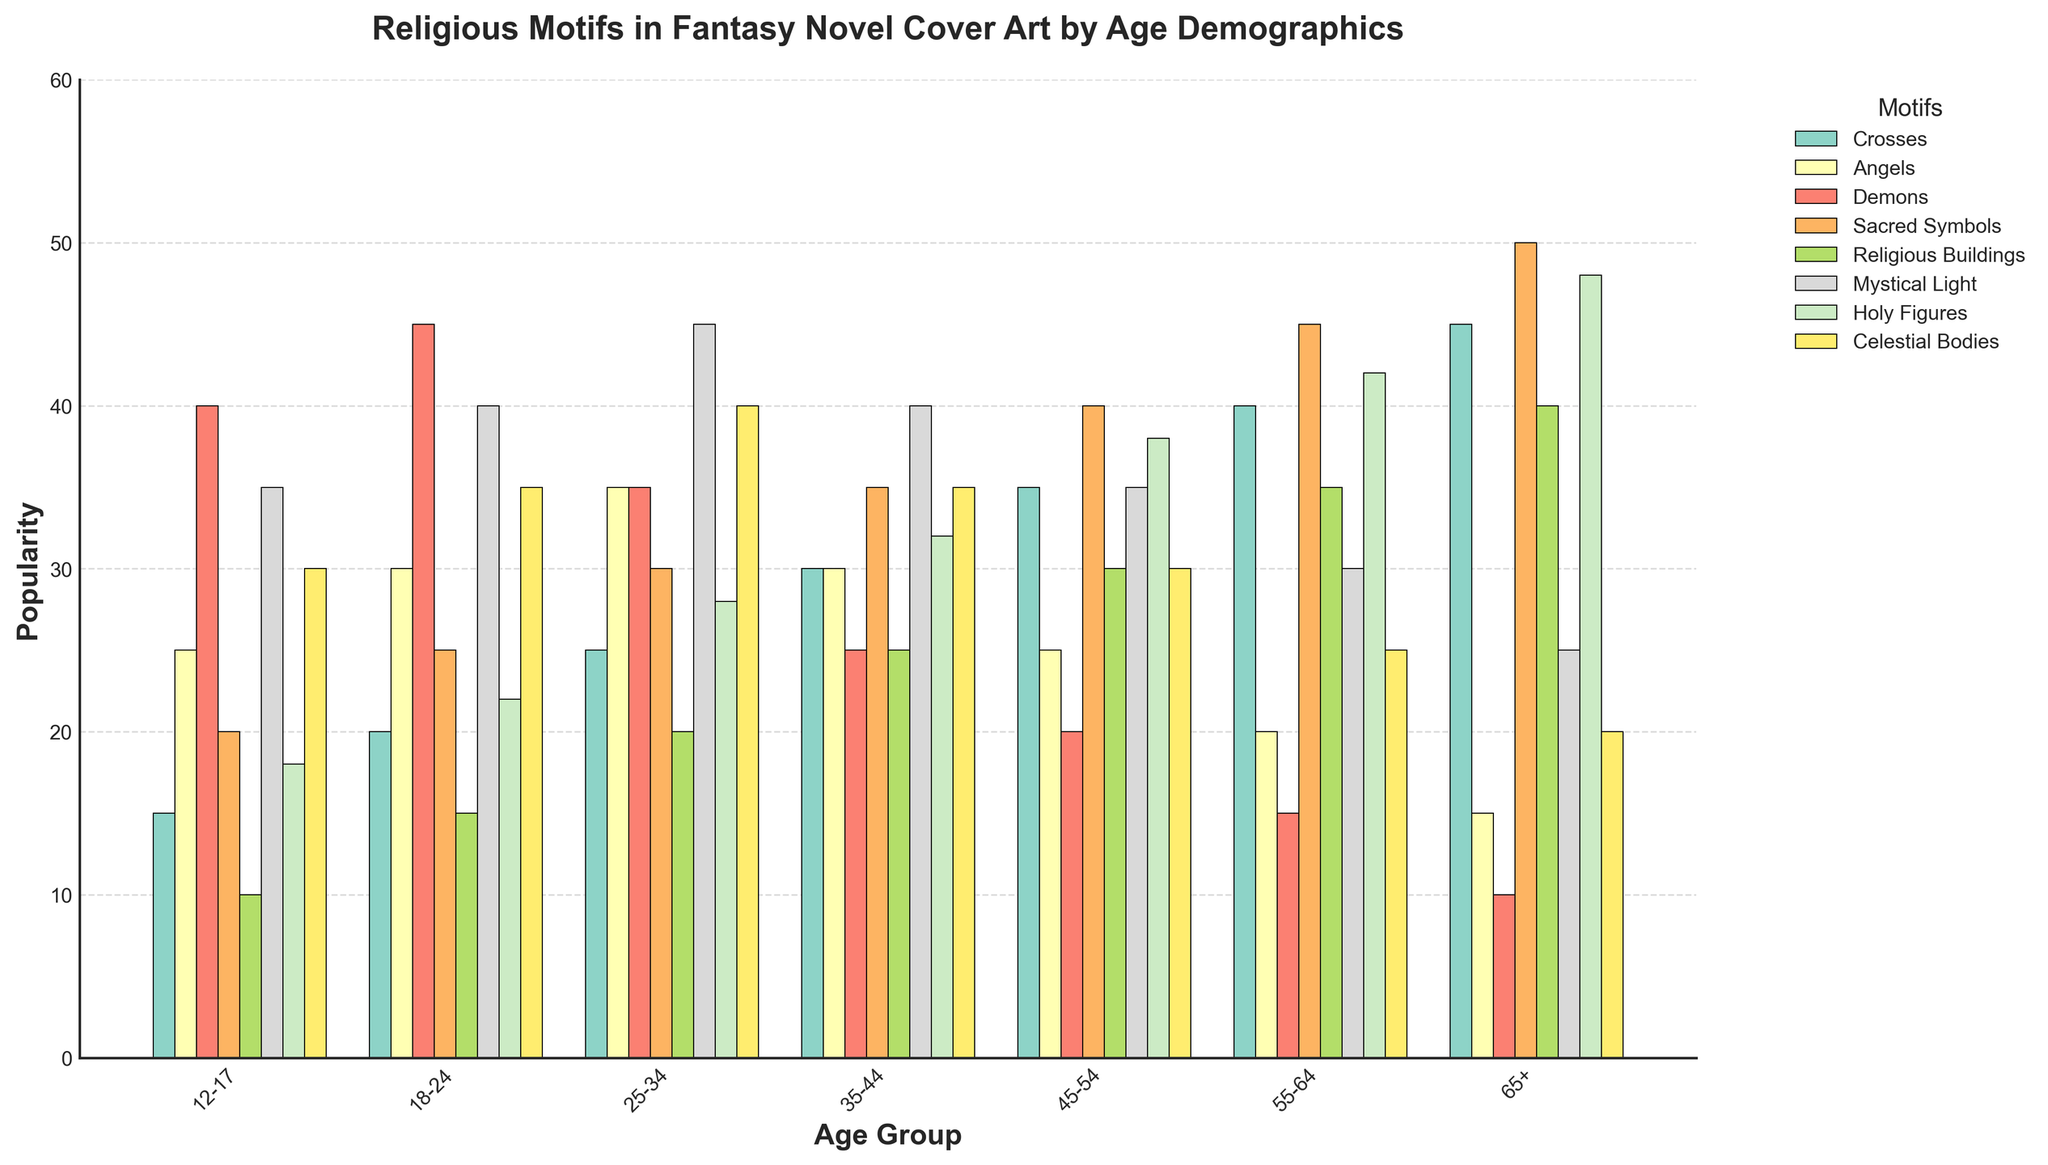Which motif is the most popular among the 18-24 age group? Look at the height of the bars for the 18-24 age group and identify the highest bar. The "Demons" motif has the highest value at 45.
Answer: Demons How does the popularity of "Holy Figures" change as age increases? Observe the trend of the "Holy Figures" motif from the 12-17 age group to the 65+ age group. There is a general increasing trend from 18 to 48 as the age group gets older.
Answer: Increases Which age group has the least interest in "Sacred Symbols" and how much is it? Identify the shortest bar for "Sacred Symbols" across all age groups. The 12-17 age group has the lowest value, which is 20.
Answer: 12-17, 20 What is the average popularity of "Mystical Light" across all age groups? Sum the values of the "Mystical Light" motif for all age groups and divide by the number of age groups (7). The average is (35+40+45+40+35+30+25)/7 = 250/7 ≈ 35.71.
Answer: 35.71 Compare the popularity of "Religious Buildings" in the 45-54 and 55-64 age groups. Which age group prefers this motif more? Compare the heights of the bars for "Religious Buildings" in the 45-54 and 55-64 age groups. The 55-64 age group has a higher value (35) compared to the 45-54 age group (30).
Answer: 55-64 Which motif shows the most consistent popularity across all age groups? Identify the motif where the heights of the bars are relatively close to each other across all age groups. "Angels" has values of 25, 30, 35, 30, 25, 20, and 15, showing a relatively small range (15).
Answer: Angels What is the difference in popularity between "Celestial Bodies" and "Crosses" in the 65+ age group? Subtract the value of "Crosses" from the value of "Celestial Bodies" for the 65+ age group. The difference is 45 (Crosses) - 20 (Celestial Bodies) = 25.
Answer: 25 Which motif has seen the largest decrease in popularity from the 12-17 to the 65+ age group? Calculate the difference in values for each motif between the 12-17 and 65+ age groups, then identify the largest decrease. "Demons" decreases from 40 to 10, a difference of 30.
Answer: Demons 